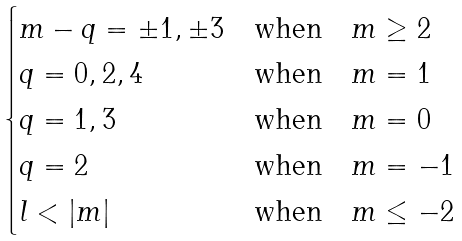<formula> <loc_0><loc_0><loc_500><loc_500>\begin{cases} m - q = \pm 1 , \pm 3 & \text {when} \quad m \geq 2 \\ q = 0 , 2 , 4 & \text {when} \quad m = 1 \\ q = 1 , 3 & \text {when} \quad m = 0 \\ q = 2 & \text {when} \quad m = - 1 \\ l < | m | & \text {when} \quad m \leq - 2 \\ \end{cases}</formula> 